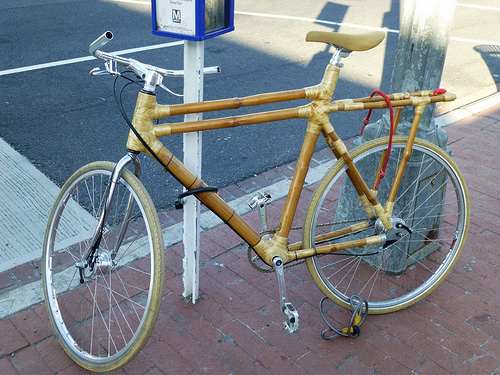<image>
Can you confirm if the bike is in front of the pole? Yes. The bike is positioned in front of the pole, appearing closer to the camera viewpoint. 